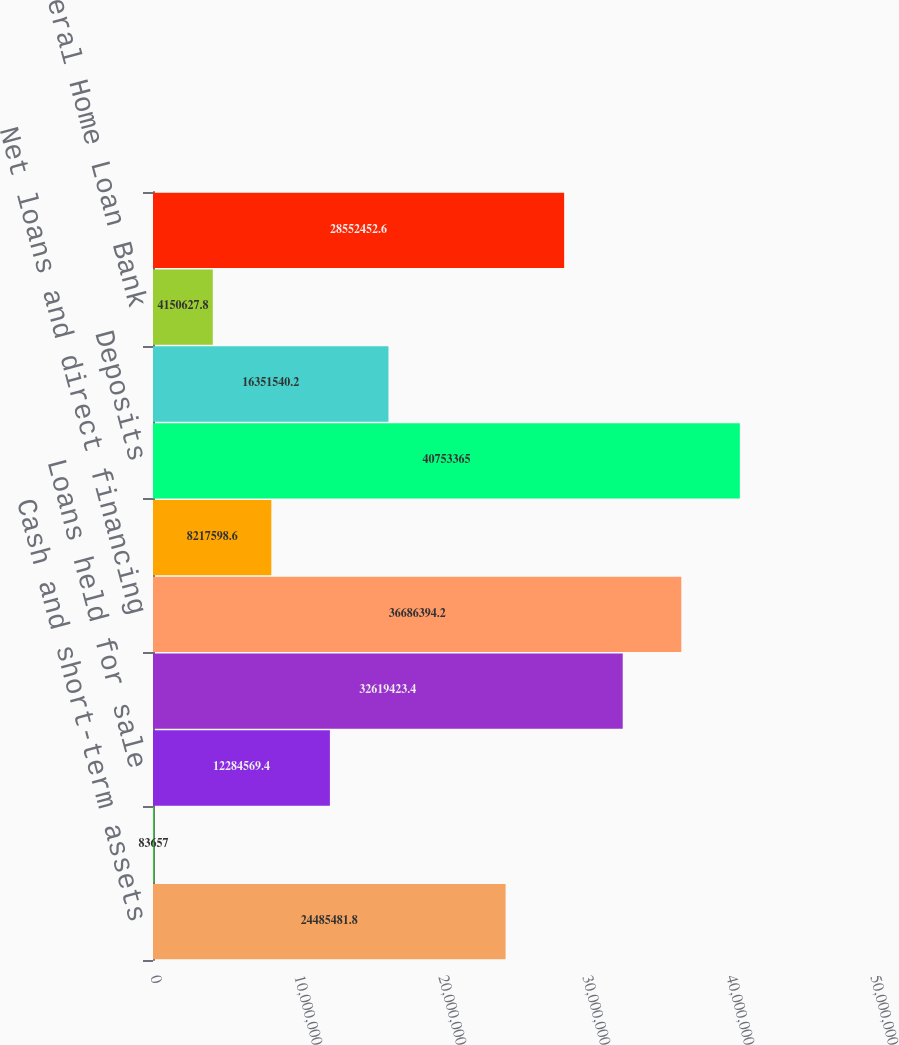Convert chart to OTSL. <chart><loc_0><loc_0><loc_500><loc_500><bar_chart><fcel>Cash and short-term assets<fcel>Trading account securities<fcel>Loans held for sale<fcel>Investment securities<fcel>Net loans and direct financing<fcel>Derivatives<fcel>Deposits<fcel>Short-term borrowings<fcel>Federal Home Loan Bank<fcel>Other long term debt<nl><fcel>2.44855e+07<fcel>83657<fcel>1.22846e+07<fcel>3.26194e+07<fcel>3.66864e+07<fcel>8.2176e+06<fcel>4.07534e+07<fcel>1.63515e+07<fcel>4.15063e+06<fcel>2.85525e+07<nl></chart> 